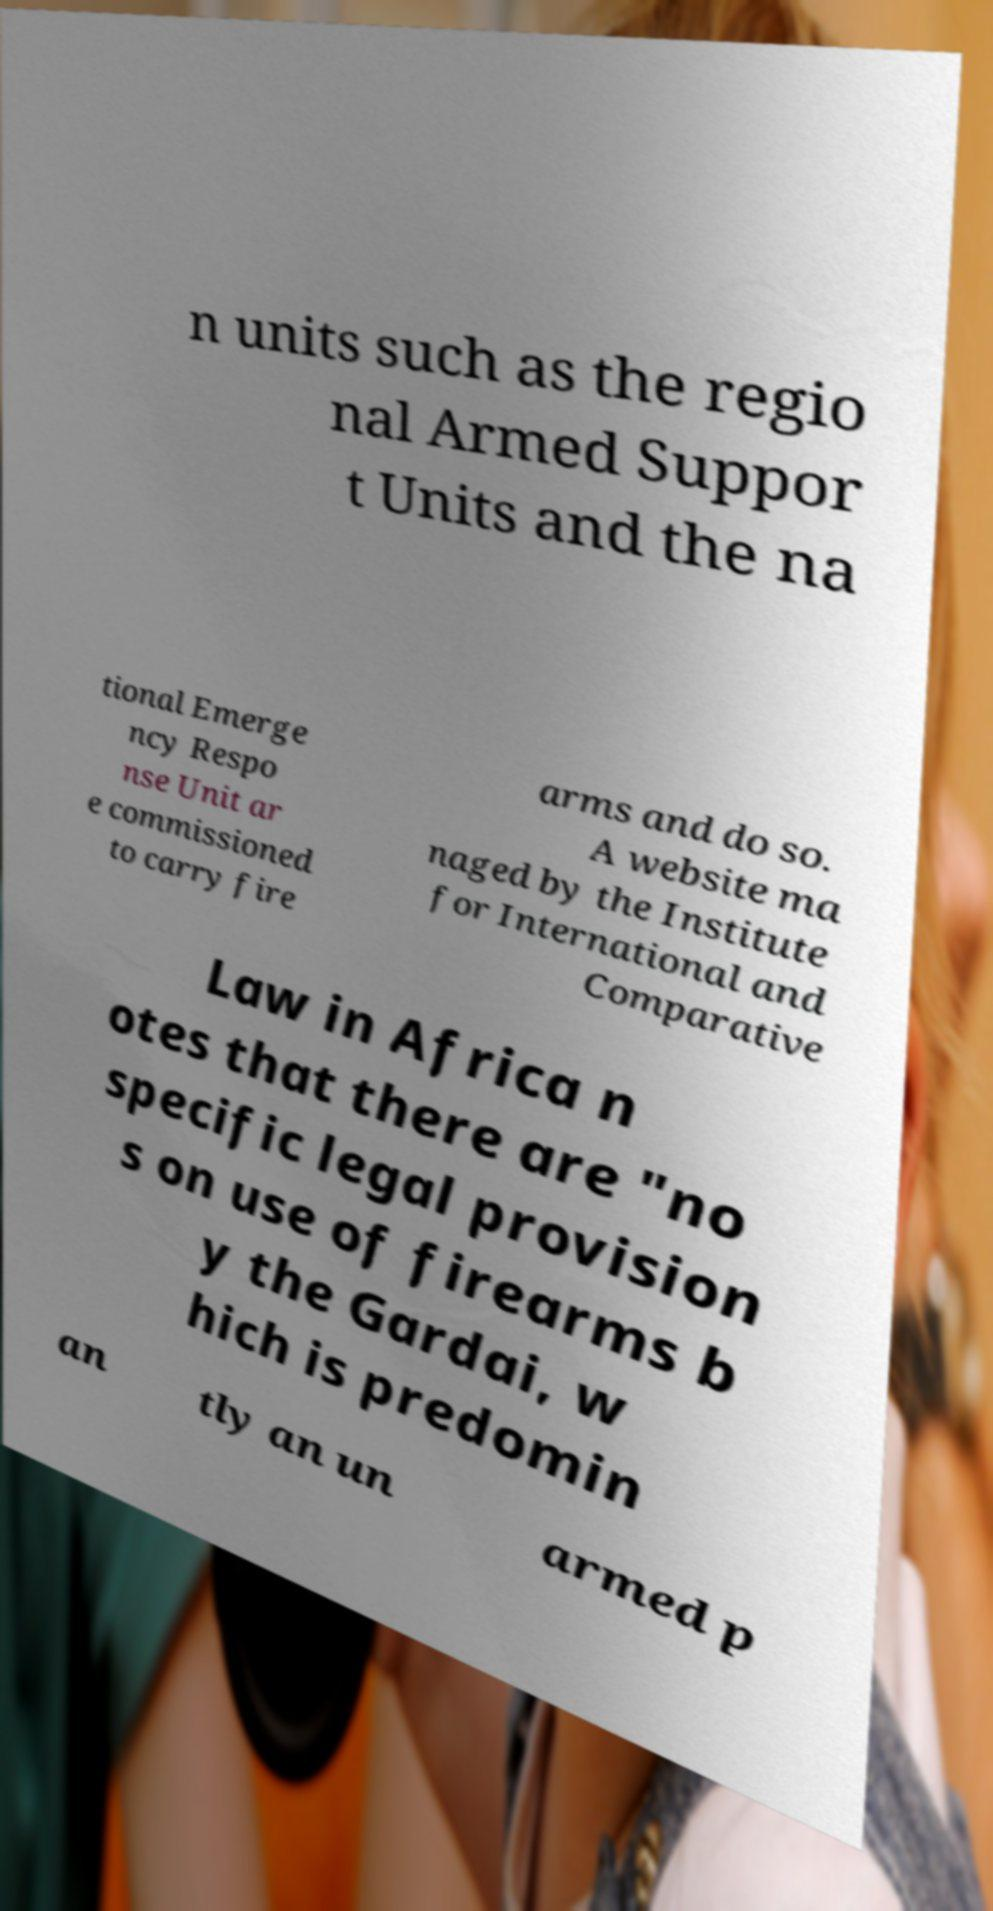Can you read and provide the text displayed in the image?This photo seems to have some interesting text. Can you extract and type it out for me? n units such as the regio nal Armed Suppor t Units and the na tional Emerge ncy Respo nse Unit ar e commissioned to carry fire arms and do so. A website ma naged by the Institute for International and Comparative Law in Africa n otes that there are "no specific legal provision s on use of firearms b y the Gardai, w hich is predomin an tly an un armed p 